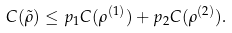Convert formula to latex. <formula><loc_0><loc_0><loc_500><loc_500>C ( \tilde { \rho } ) \leq p _ { 1 } C ( \rho ^ { ( 1 ) } ) + p _ { 2 } C ( \rho ^ { ( 2 ) } ) .</formula> 